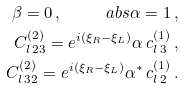<formula> <loc_0><loc_0><loc_500><loc_500>\beta = 0 \, , \quad \ a b s { \alpha } = 1 \, , \\ C ^ { ( 2 ) } _ { l \, 2 3 } = e ^ { i ( \xi _ { R } - \xi _ { L } ) } \alpha \, c ^ { ( 1 ) } _ { l \, 3 } \, , \\ C ^ { ( 2 ) } _ { l \, 3 2 } = e ^ { i ( \xi _ { R } - \xi _ { L } ) } \alpha ^ { \ast } \, c ^ { ( 1 ) } _ { l \, 2 } \, .</formula> 